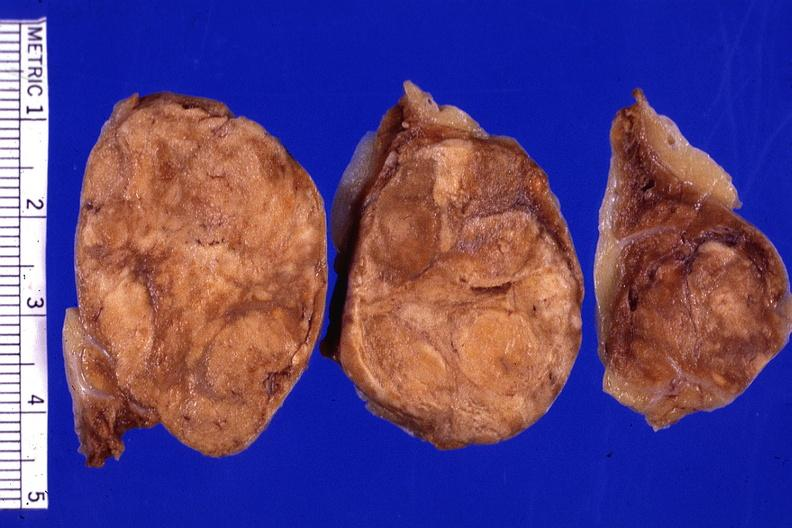where does this belong to?
Answer the question using a single word or phrase. Endocrine system 